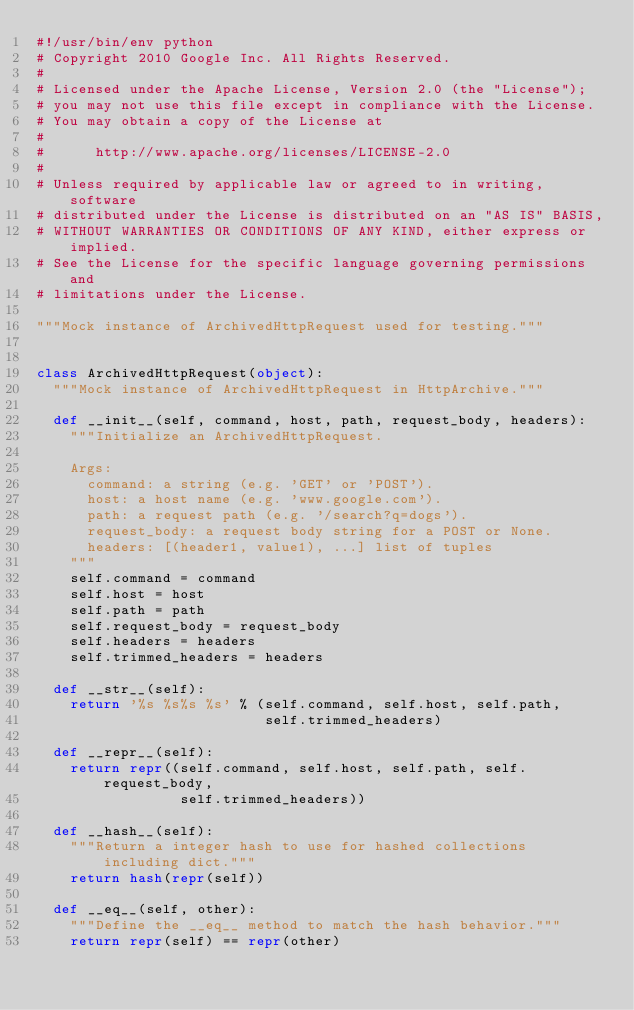Convert code to text. <code><loc_0><loc_0><loc_500><loc_500><_Python_>#!/usr/bin/env python
# Copyright 2010 Google Inc. All Rights Reserved.
#
# Licensed under the Apache License, Version 2.0 (the "License");
# you may not use this file except in compliance with the License.
# You may obtain a copy of the License at
#
#      http://www.apache.org/licenses/LICENSE-2.0
#
# Unless required by applicable law or agreed to in writing, software
# distributed under the License is distributed on an "AS IS" BASIS,
# WITHOUT WARRANTIES OR CONDITIONS OF ANY KIND, either express or implied.
# See the License for the specific language governing permissions and
# limitations under the License.

"""Mock instance of ArchivedHttpRequest used for testing."""


class ArchivedHttpRequest(object):
  """Mock instance of ArchivedHttpRequest in HttpArchive."""

  def __init__(self, command, host, path, request_body, headers):
    """Initialize an ArchivedHttpRequest.

    Args:
      command: a string (e.g. 'GET' or 'POST').
      host: a host name (e.g. 'www.google.com').
      path: a request path (e.g. '/search?q=dogs').
      request_body: a request body string for a POST or None.
      headers: [(header1, value1), ...] list of tuples
    """
    self.command = command
    self.host = host
    self.path = path
    self.request_body = request_body
    self.headers = headers
    self.trimmed_headers = headers

  def __str__(self):
    return '%s %s%s %s' % (self.command, self.host, self.path,
                           self.trimmed_headers)

  def __repr__(self):
    return repr((self.command, self.host, self.path, self.request_body,
                 self.trimmed_headers))

  def __hash__(self):
    """Return a integer hash to use for hashed collections including dict."""
    return hash(repr(self))

  def __eq__(self, other):
    """Define the __eq__ method to match the hash behavior."""
    return repr(self) == repr(other)
</code> 